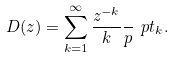Convert formula to latex. <formula><loc_0><loc_0><loc_500><loc_500>D ( z ) = \sum _ { k = 1 } ^ { \infty } \frac { z ^ { - k } } k \frac { \ } { p } { \ p t _ { k } } .</formula> 